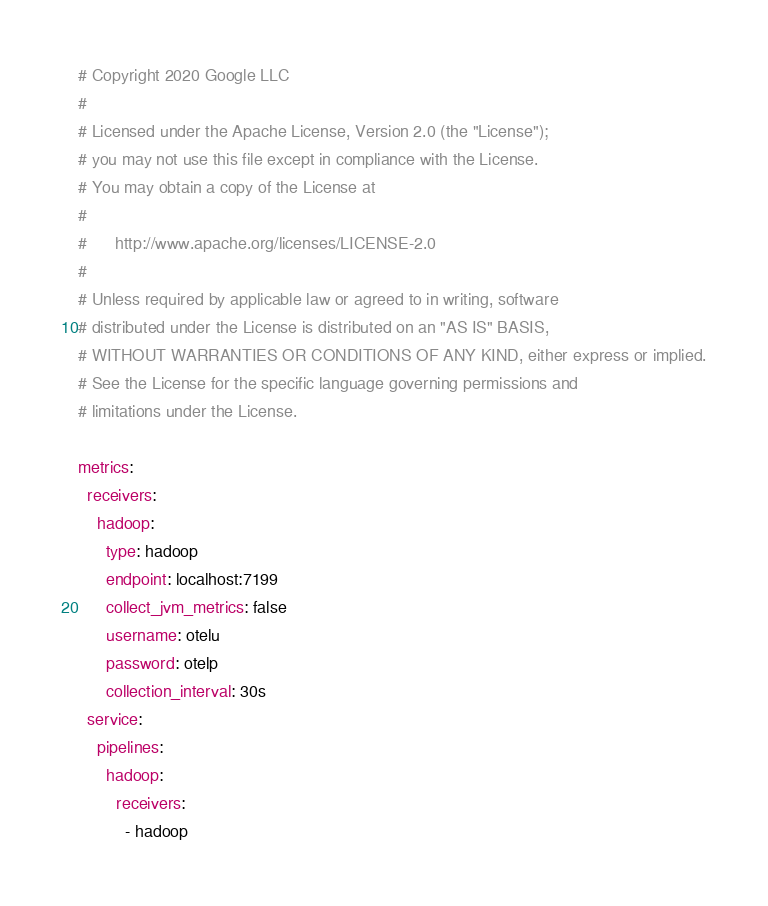Convert code to text. <code><loc_0><loc_0><loc_500><loc_500><_YAML_># Copyright 2020 Google LLC
#
# Licensed under the Apache License, Version 2.0 (the "License");
# you may not use this file except in compliance with the License.
# You may obtain a copy of the License at
#
#      http://www.apache.org/licenses/LICENSE-2.0
#
# Unless required by applicable law or agreed to in writing, software
# distributed under the License is distributed on an "AS IS" BASIS,
# WITHOUT WARRANTIES OR CONDITIONS OF ANY KIND, either express or implied.
# See the License for the specific language governing permissions and
# limitations under the License.

metrics:
  receivers:
    hadoop:
      type: hadoop
      endpoint: localhost:7199
      collect_jvm_metrics: false
      username: otelu
      password: otelp
      collection_interval: 30s
  service:
    pipelines:
      hadoop:
        receivers:
          - hadoop
</code> 